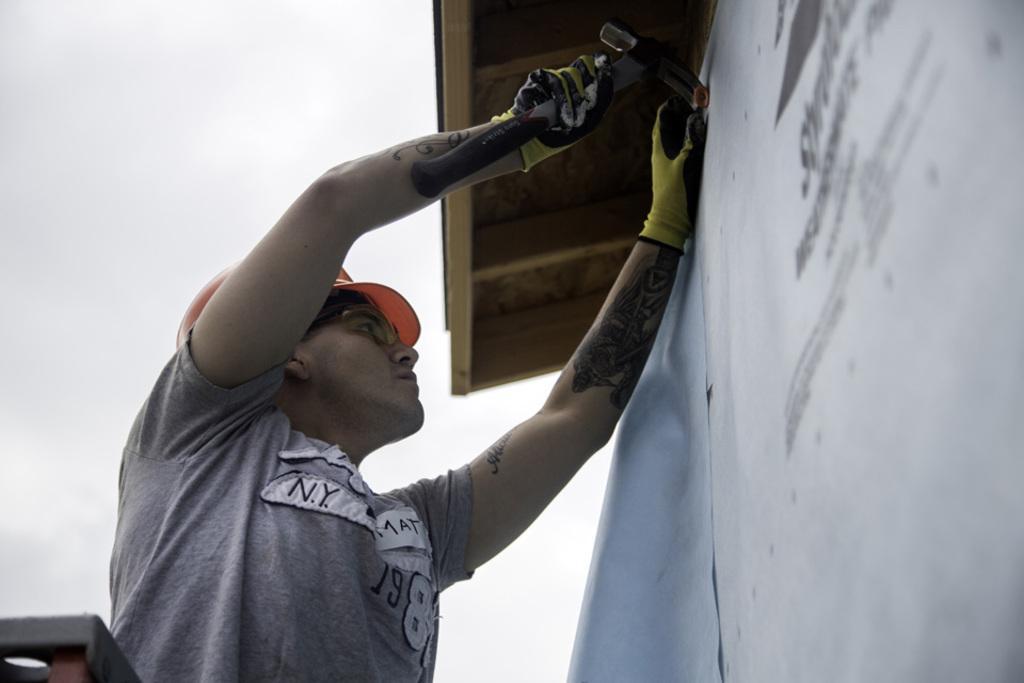Please provide a concise description of this image. In this picture we can see a person hitting a nail in the wall with a hammer. At the top we can see the wooden roof. 